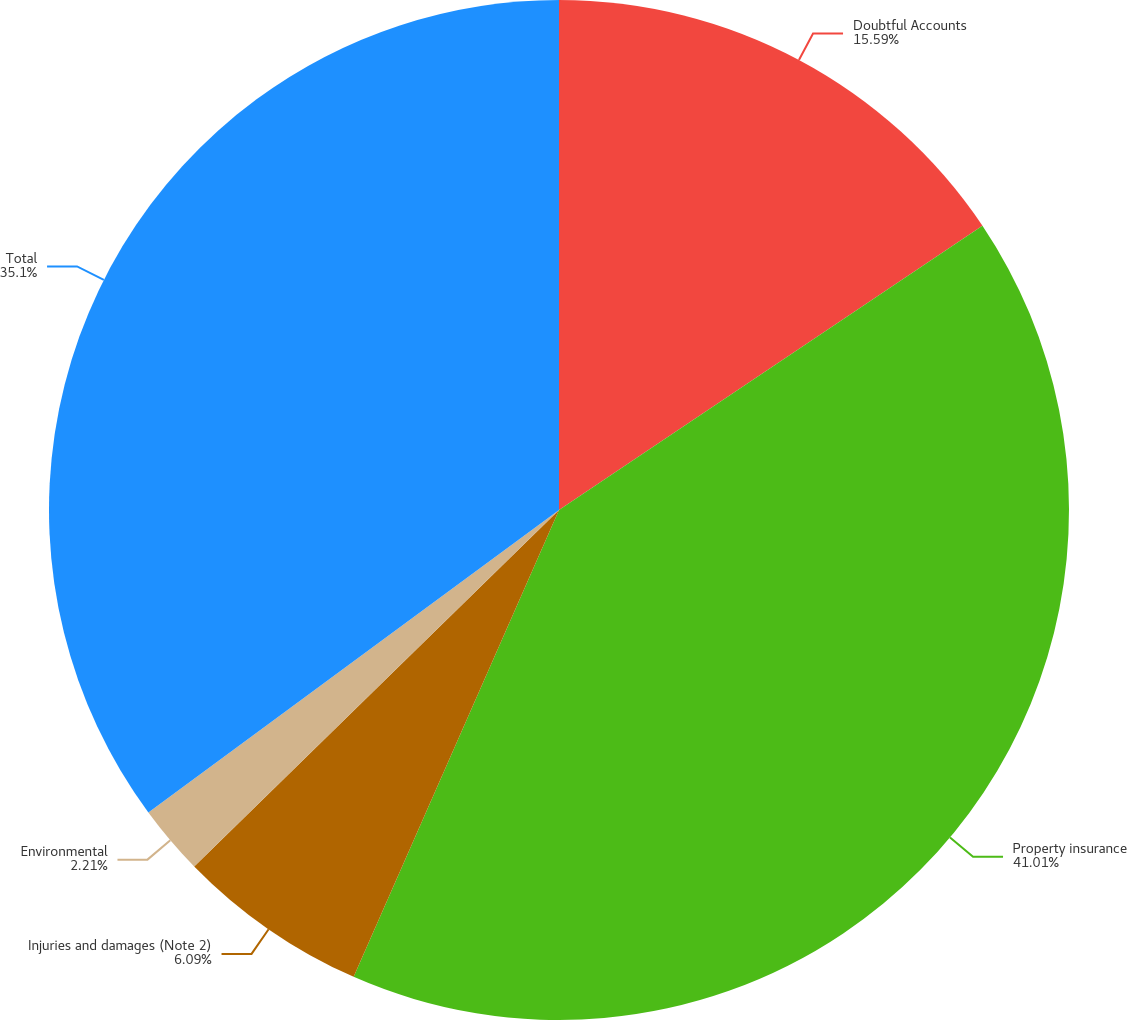Convert chart. <chart><loc_0><loc_0><loc_500><loc_500><pie_chart><fcel>Doubtful Accounts<fcel>Property insurance<fcel>Injuries and damages (Note 2)<fcel>Environmental<fcel>Total<nl><fcel>15.59%<fcel>41.0%<fcel>6.09%<fcel>2.21%<fcel>35.1%<nl></chart> 